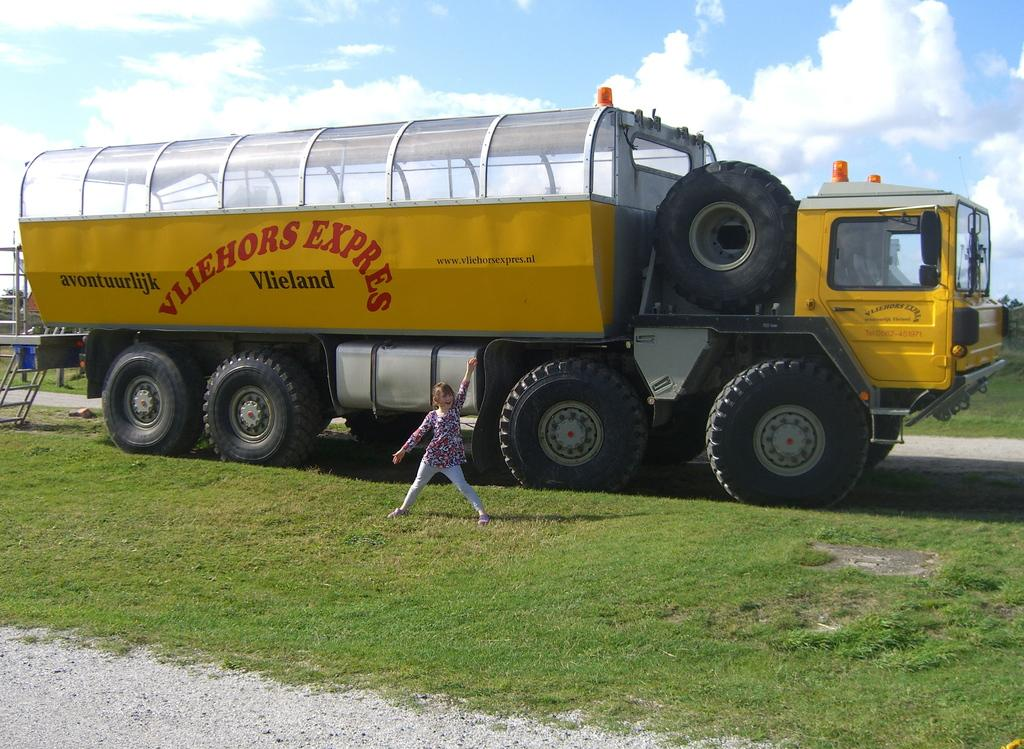What is the main subject in the center of the image? There is a vehicle in the center of the image. Can you describe the position of the vehicle in the image? The vehicle is on the ground in the image. Who or what else can be seen in the image? There is a kid in the image. What is visible in the sky at the top of the image? There are clouds in the sky at the top of the image. What type of stem can be seen growing from the vehicle in the image? There is no stem growing from the vehicle in the image. What stage of the performance is the kid participating in the image? There is no performance or stage present in the image; it features a vehicle and a kid. 